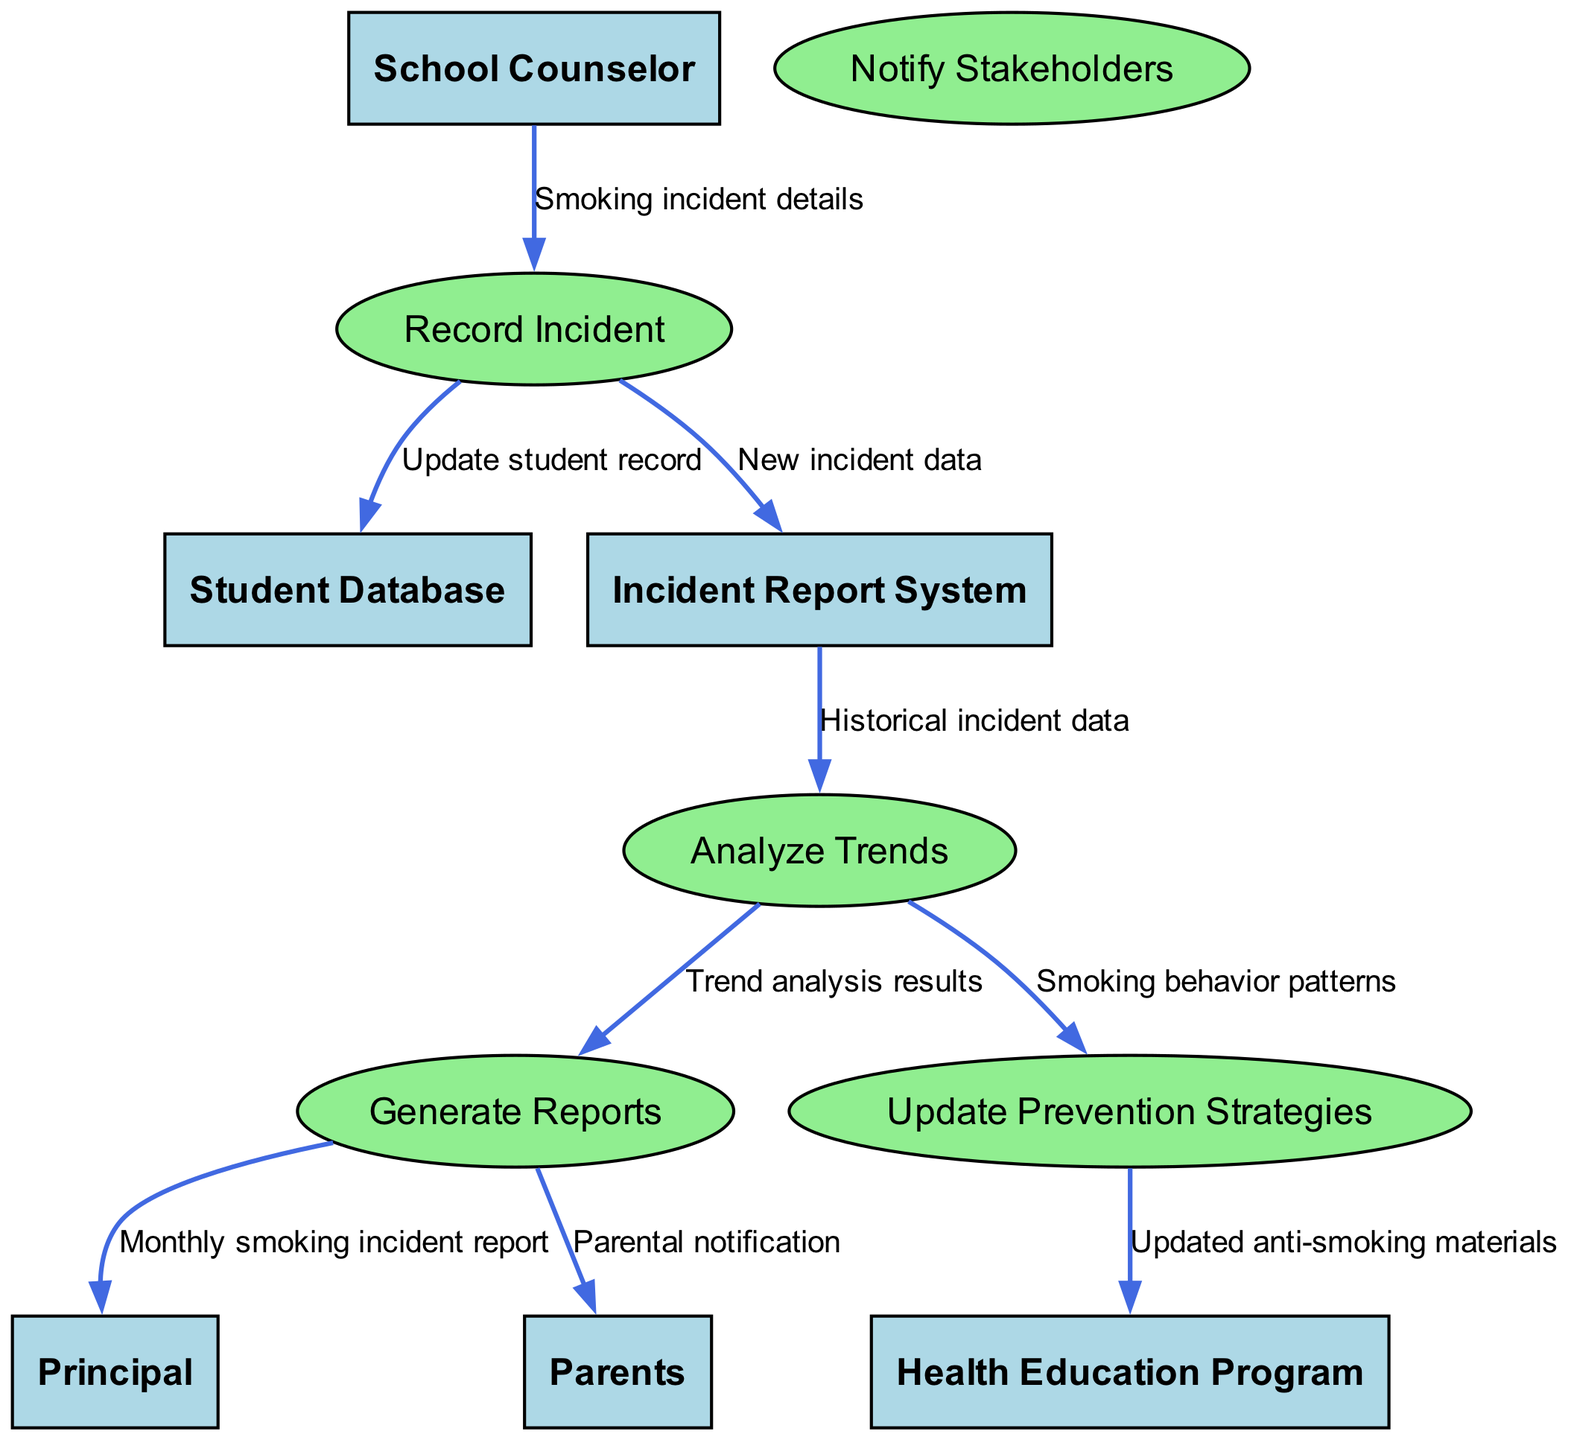What is the total number of entities in the diagram? The diagram lists five entities: School Counselor, Student Database, Incident Report System, Principal, and Parents. By counting these, we find the total number of entities is five.
Answer: 5 Which process is connected to the Principal? The process connected to the Principal is Generate Reports. This can be identified by tracing the flow from Generate Reports to the Principal node.
Answer: Generate Reports What type of information does the School Counselor provide to Record Incident? The information provided by the School Counselor to Record Incident consists of Smoking incident details. This is indicated by the label on the connecting arrow from School Counselor to Record Incident.
Answer: Smoking incident details How many data flows are directed towards the Health Education Program? There is one data flow directed towards the Health Education Program, which is from Update Prevention Strategies. This can be confirmed by analyzing the connections leading to the Health Education Program node.
Answer: 1 What data does Analyze Trends use as input? Analyze Trends uses Historical incident data as input. This is shown by observing the arrow from Incident Report System to Analyze Trends labeled as such.
Answer: Historical incident data Which stakeholders are notified after generating reports? After generating reports, the stakeholders notified are the Principal and Parents. By checking the arrows leading from Generate Reports, we note there are connections to both the Principal and Parents.
Answer: Principal and Parents What is the output of the Analyze Trends process? The output of the Analyze Trends process consists of two main outputs: Trend analysis results directed to Generate Reports, and Smoking behavior patterns directed to Update Prevention Strategies. Each output can be found on the respective outgoing arrows from Analyze Trends.
Answer: Trend analysis results, Smoking behavior patterns Which process updates the student record after a smoking incident is recorded? After a smoking incident is recorded, the process that updates the student record is Record Incident. This can be deduced from the flow of information that moves from Record Incident to Student Database, indicating that the record is updated as part of that process.
Answer: Record Incident What materials are updated for the Health Education Program? The updated materials for the Health Education Program are the Updated anti-smoking materials, which are transmitted from the Update Prevention Strategies process. This relationship can be traced through the connection from Update Prevention Strategies to the Health Education Program node.
Answer: Updated anti-smoking materials 